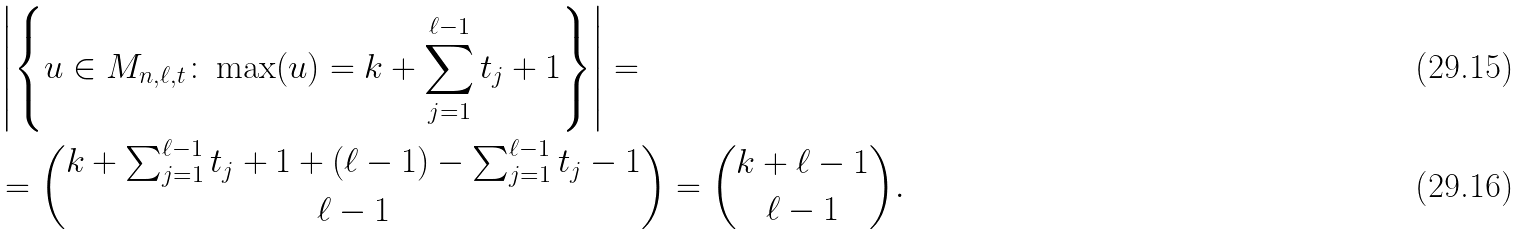<formula> <loc_0><loc_0><loc_500><loc_500>& \left | \left \{ u \in M _ { n , \ell , { t } } \colon \max ( u ) = k + \sum _ { j = 1 } ^ { \ell - 1 } t _ { j } + 1 \right \} \right | = \\ & = \binom { k + \sum _ { j = 1 } ^ { \ell - 1 } t _ { j } + 1 + ( \ell - 1 ) - \sum _ { j = 1 } ^ { \ell - 1 } t _ { j } - 1 } { \ell - 1 } = \binom { k + \ell - 1 } { \ell - 1 } .</formula> 